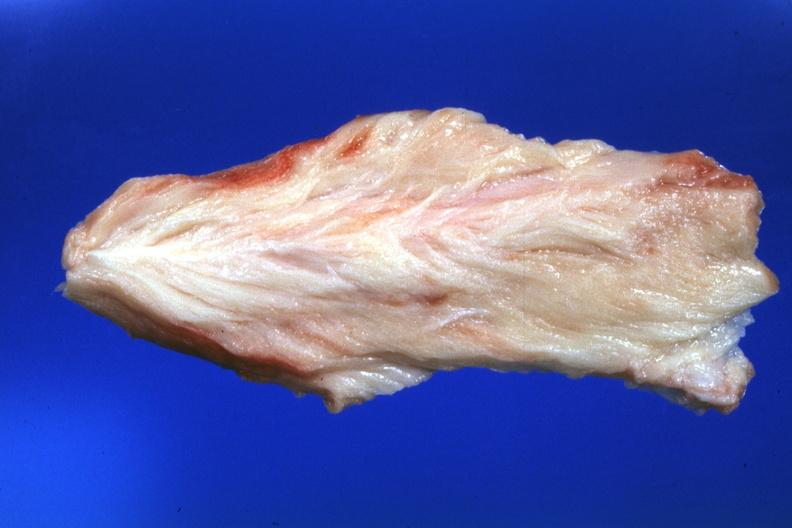does this image show close-up very pale muscle?
Answer the question using a single word or phrase. Yes 